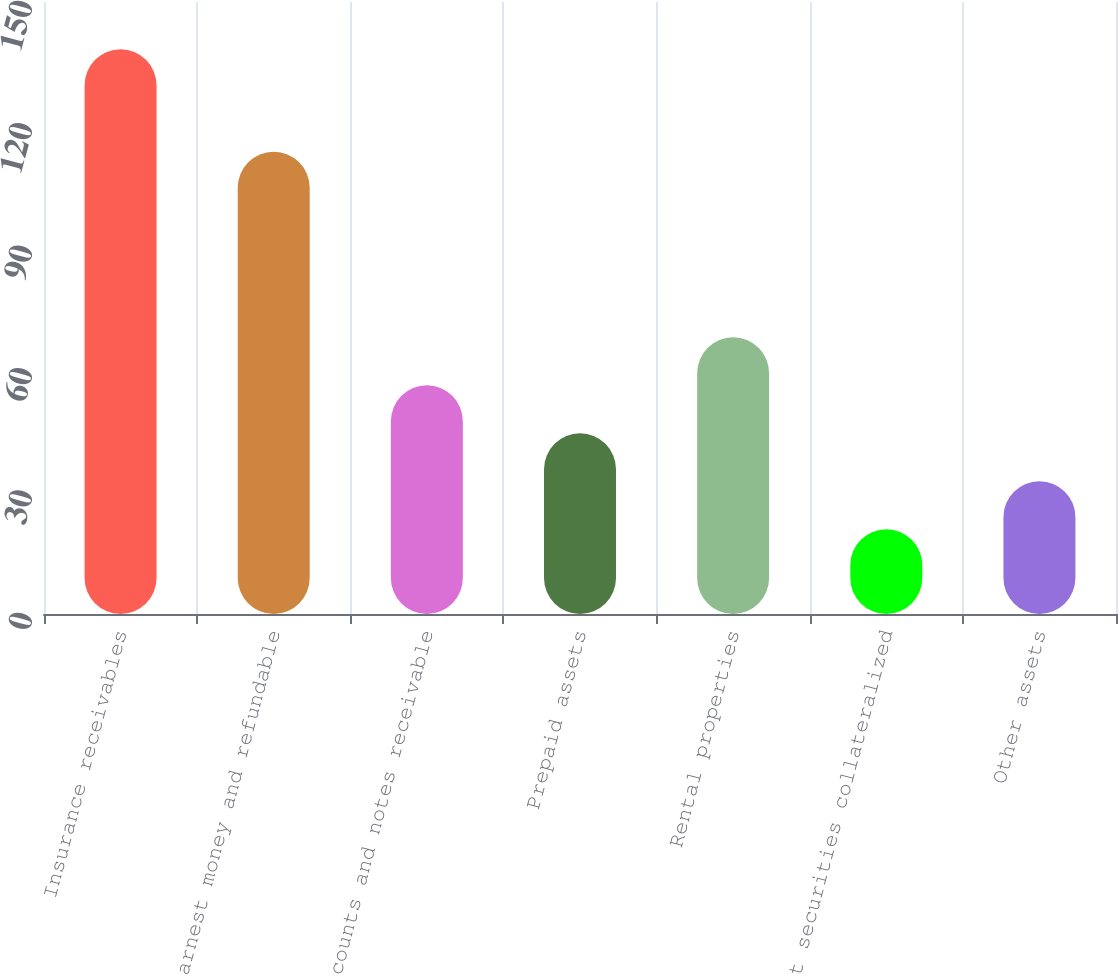Convert chart to OTSL. <chart><loc_0><loc_0><loc_500><loc_500><bar_chart><fcel>Insurance receivables<fcel>Earnest money and refundable<fcel>Accounts and notes receivable<fcel>Prepaid assets<fcel>Rental properties<fcel>Debt securities collateralized<fcel>Other assets<nl><fcel>138.4<fcel>113.3<fcel>56.08<fcel>44.32<fcel>67.84<fcel>20.8<fcel>32.56<nl></chart> 